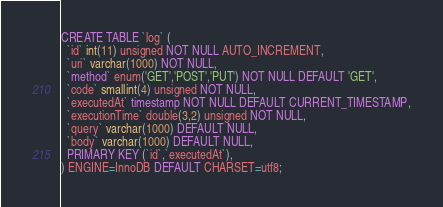Convert code to text. <code><loc_0><loc_0><loc_500><loc_500><_SQL_>CREATE TABLE `log` (
  `id` int(11) unsigned NOT NULL AUTO_INCREMENT,
  `uri` varchar(1000) NOT NULL,
  `method` enum('GET','POST','PUT') NOT NULL DEFAULT 'GET',
  `code` smallint(4) unsigned NOT NULL,
  `executedAt` timestamp NOT NULL DEFAULT CURRENT_TIMESTAMP,
  `executionTime` double(3,2) unsigned NOT NULL,
  `query` varchar(1000) DEFAULT NULL,
  `body` varchar(1000) DEFAULT NULL,
  PRIMARY KEY (`id`,`executedAt`),
) ENGINE=InnoDB DEFAULT CHARSET=utf8;</code> 